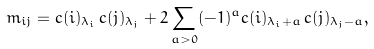<formula> <loc_0><loc_0><loc_500><loc_500>m _ { i j } = c ( i ) _ { \lambda _ { i } } \, c ( j ) _ { \lambda _ { j } } + 2 \sum _ { a > 0 } ( - 1 ) ^ { a } c ( i ) _ { \lambda _ { i } + a } \, c ( j ) _ { \lambda _ { j } - a } ,</formula> 